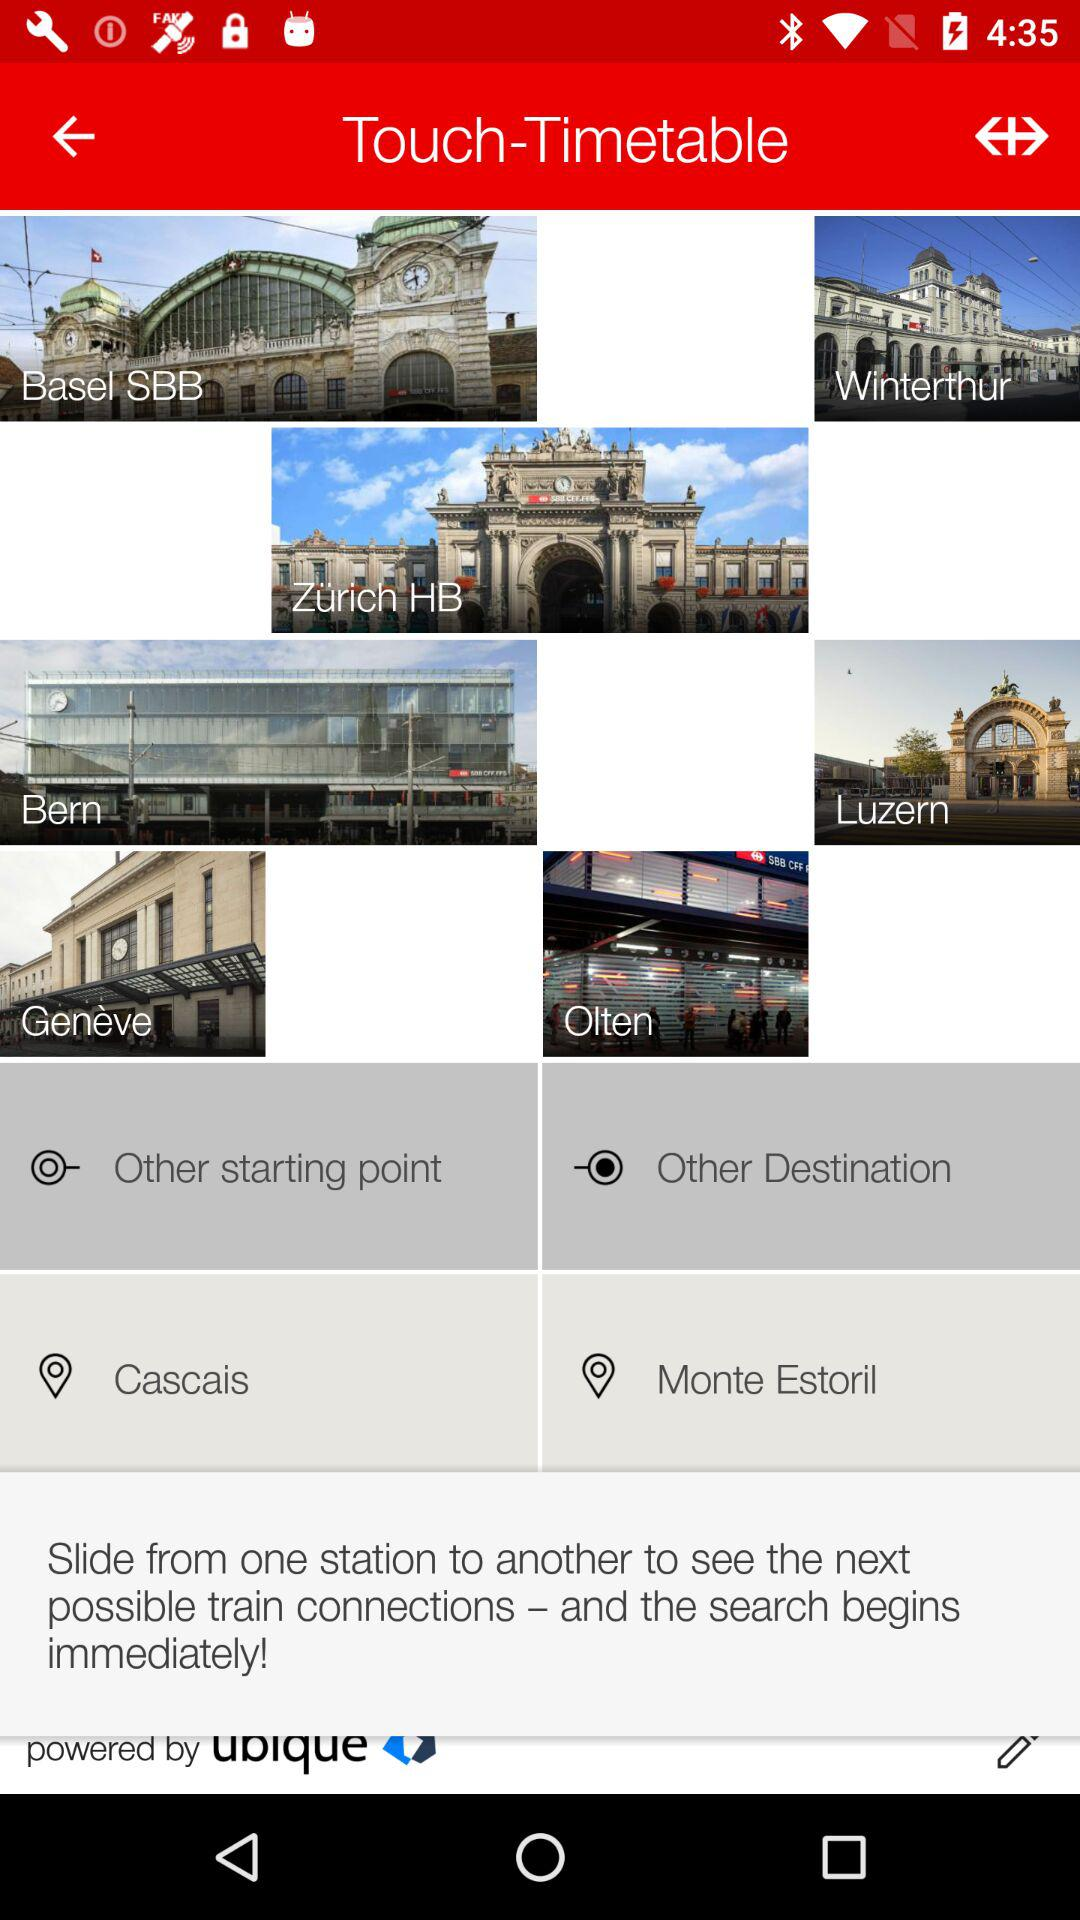What is the destination? The destination is Monte Estoril. 